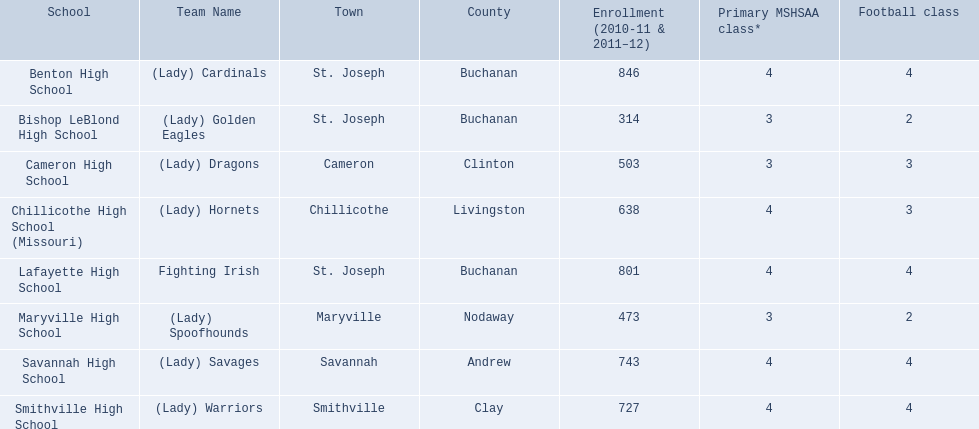What are the three schools in the town of st. joseph? St. Joseph, St. Joseph, St. Joseph. Of the three schools in st. joseph which school's team name does not depict a type of animal? Lafayette High School. 